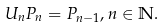Convert formula to latex. <formula><loc_0><loc_0><loc_500><loc_500>U _ { n } P _ { n } = P _ { n - 1 } , n \in \mathbb { N } .</formula> 